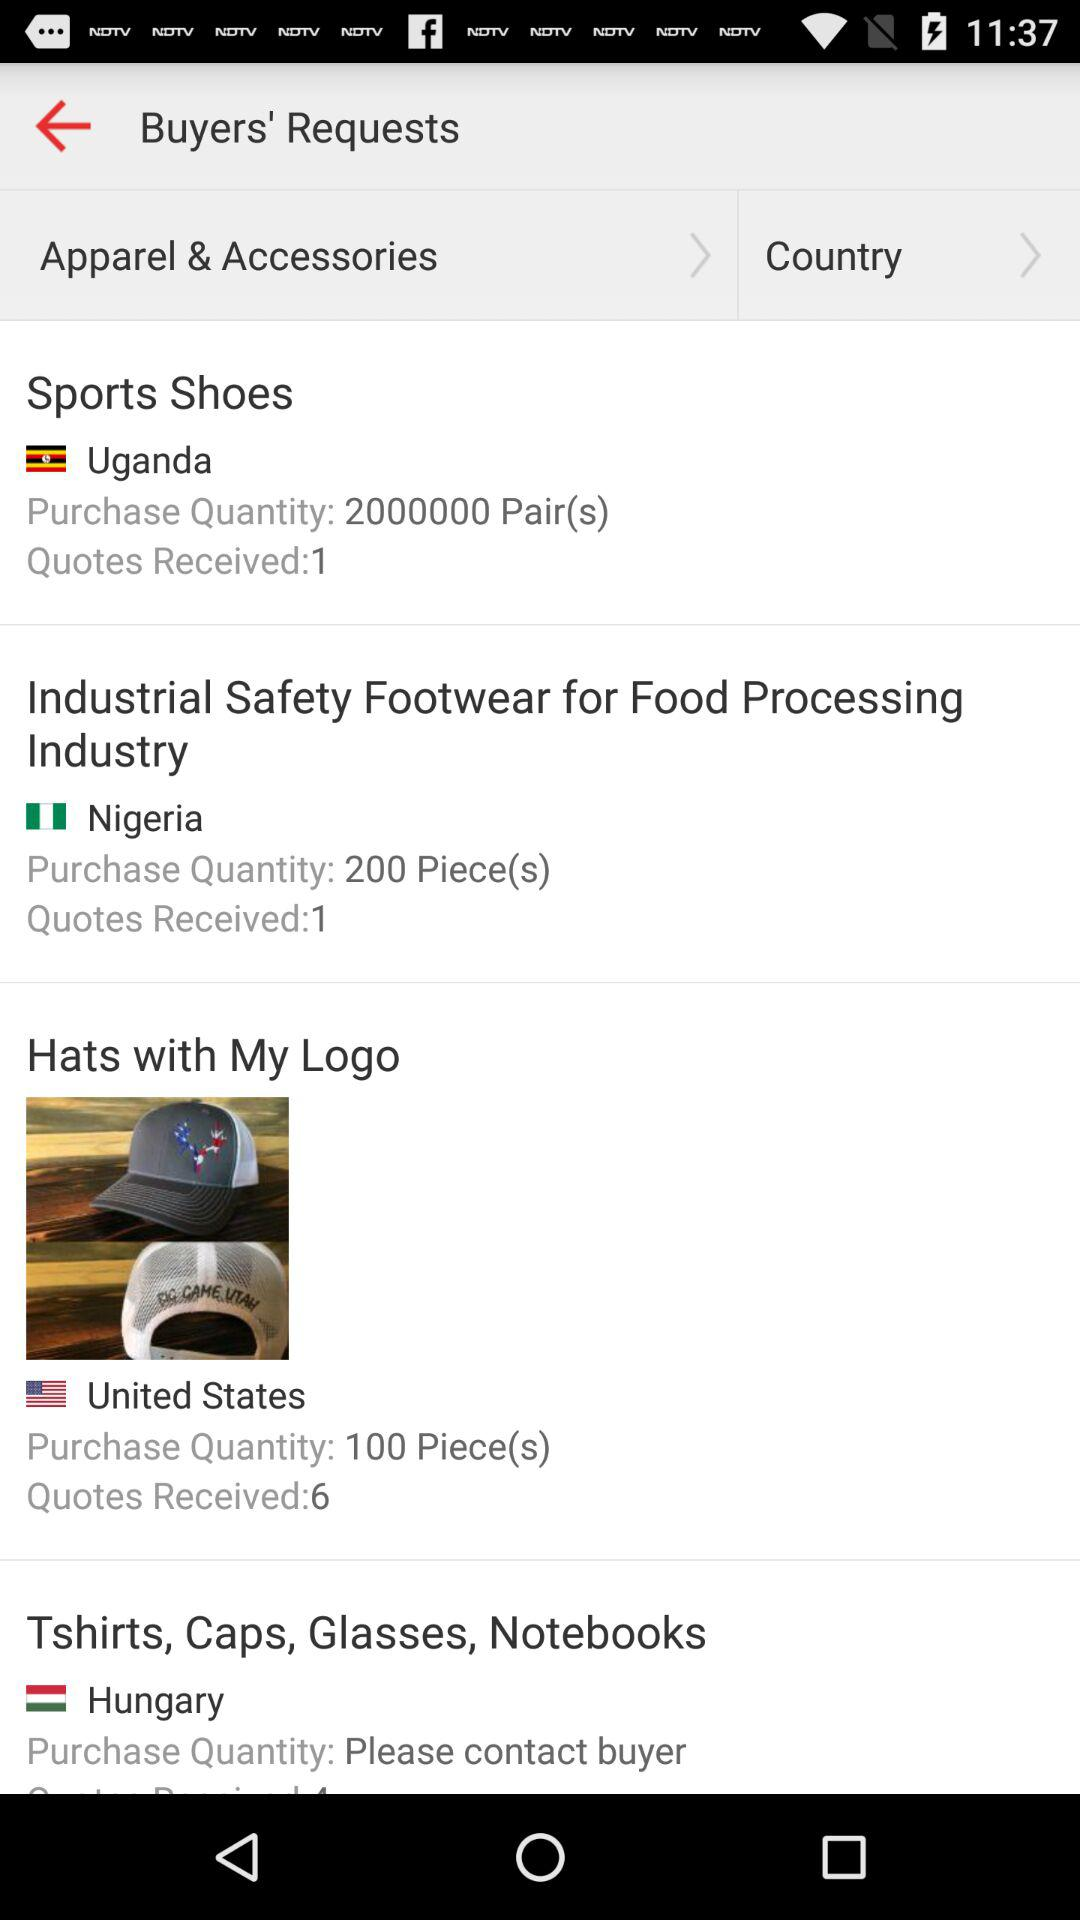What is the purchase quantity of safety footwear in Nigeria? The purchase quantity of safety footwear is 200 pieces. 